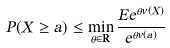<formula> <loc_0><loc_0><loc_500><loc_500>P ( X \geq a ) \leq \min _ { \theta \in \mathbf R } \frac { E e ^ { \theta v ( X ) } } { e ^ { \theta v ( a ) } }</formula> 